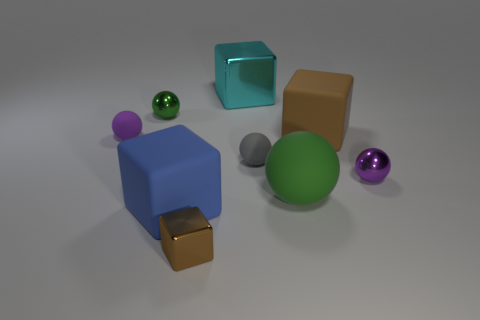What number of objects are either small purple spheres that are left of the big green matte object or objects on the right side of the big brown rubber object?
Your answer should be compact. 2. Do the metal thing in front of the big rubber ball and the small metal object to the right of the brown shiny thing have the same shape?
Ensure brevity in your answer.  No. The purple metallic object that is the same size as the purple rubber object is what shape?
Your response must be concise. Sphere. What number of metal things are cyan blocks or big blue objects?
Give a very brief answer. 1. Are the green thing behind the green rubber thing and the brown object right of the brown metal block made of the same material?
Offer a very short reply. No. There is another tiny sphere that is the same material as the small green sphere; what is its color?
Your response must be concise. Purple. Are there more big cyan objects behind the big green thing than brown rubber blocks on the right side of the tiny green ball?
Keep it short and to the point. No. Is there a blue rubber ball?
Your answer should be very brief. No. There is a tiny sphere that is the same color as the big ball; what is it made of?
Your response must be concise. Metal. How many things are purple shiny objects or green matte things?
Provide a short and direct response. 2. 